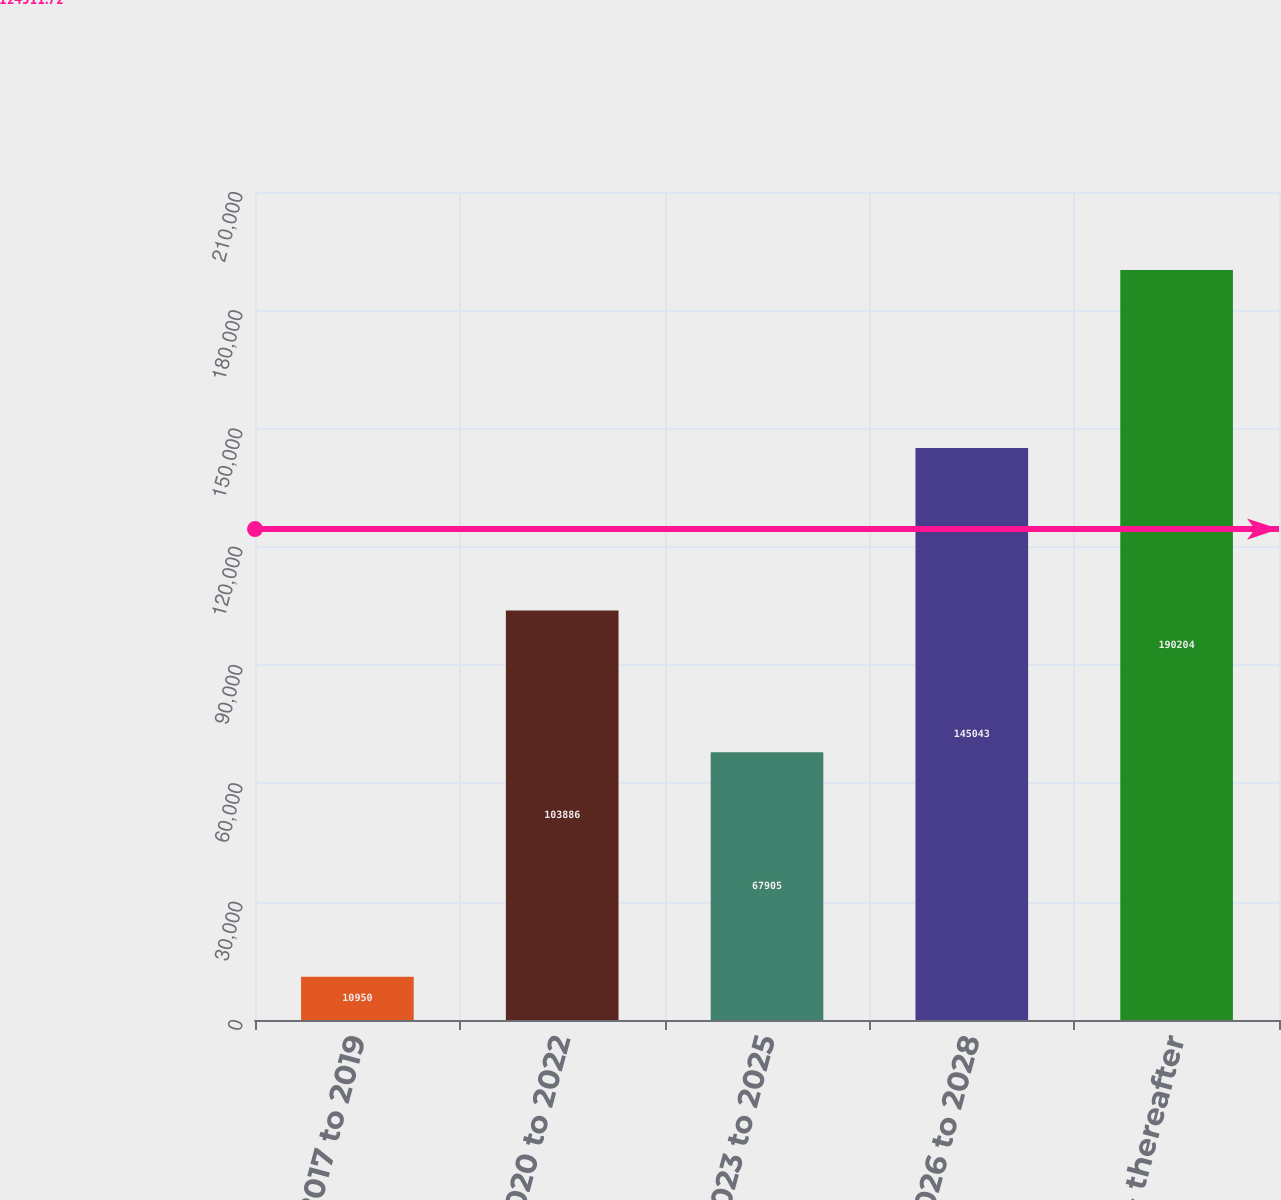<chart> <loc_0><loc_0><loc_500><loc_500><bar_chart><fcel>2017 to 2019<fcel>2020 to 2022<fcel>2023 to 2025<fcel>2026 to 2028<fcel>2029 & thereafter<nl><fcel>10950<fcel>103886<fcel>67905<fcel>145043<fcel>190204<nl></chart> 